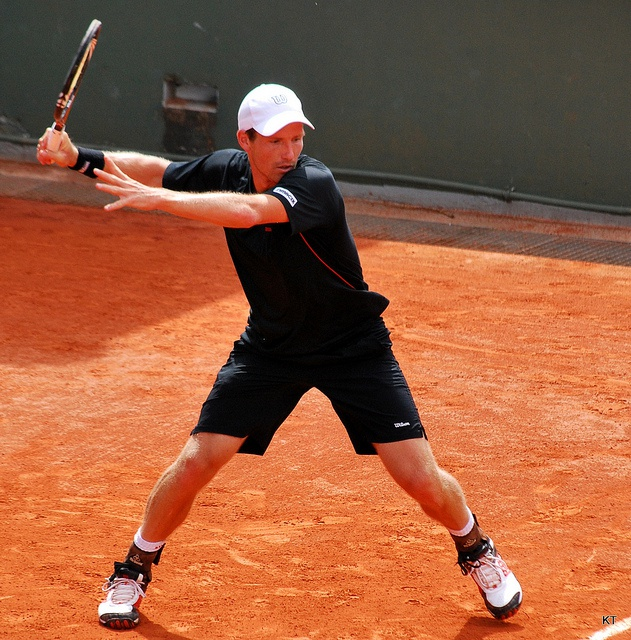Describe the objects in this image and their specific colors. I can see people in black, brown, and white tones and tennis racket in black, maroon, gray, and lightgray tones in this image. 